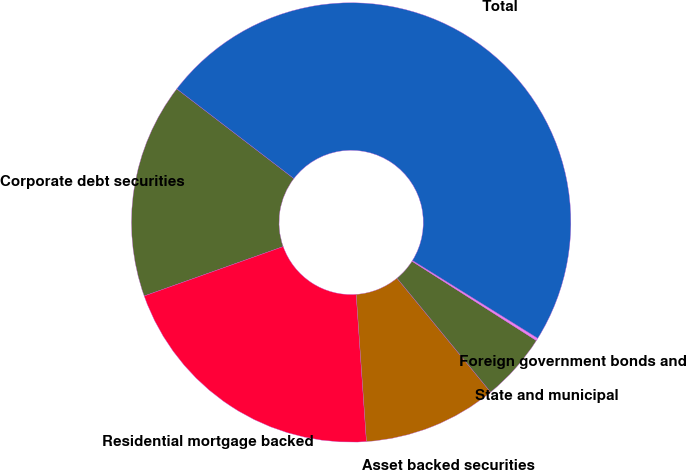Convert chart. <chart><loc_0><loc_0><loc_500><loc_500><pie_chart><fcel>Corporate debt securities<fcel>Residential mortgage backed<fcel>Asset backed securities<fcel>State and municipal<fcel>Foreign government bonds and<fcel>Total<nl><fcel>15.84%<fcel>20.67%<fcel>9.84%<fcel>5.02%<fcel>0.19%<fcel>48.44%<nl></chart> 